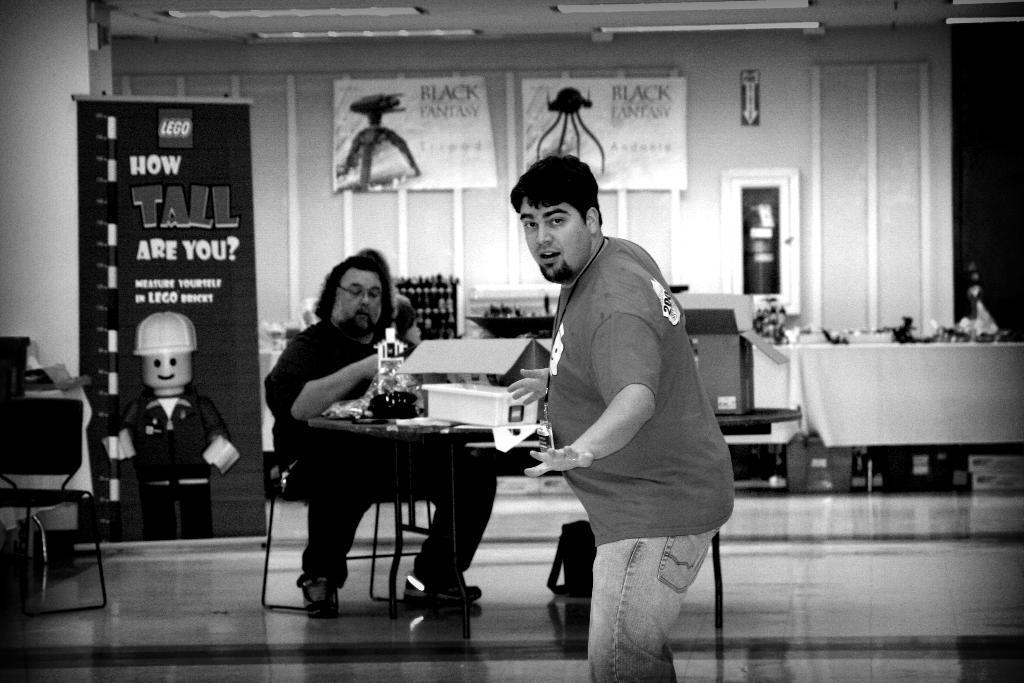How would you summarize this image in a sentence or two? In the center of the image a man is sitting on a chair, other man is standing. On the left side of the image we can see board, chair are present. On the right side of the image a table is there. On the table some objects are present. In the background of the image we can see lights, board, boxes are present. At the bottom of the image we can see bag and floor are there. 